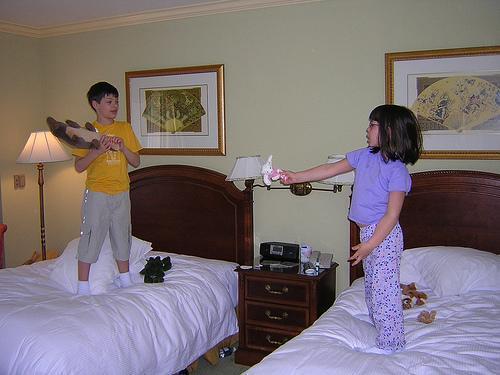How many people in the photo?
Give a very brief answer. 2. 